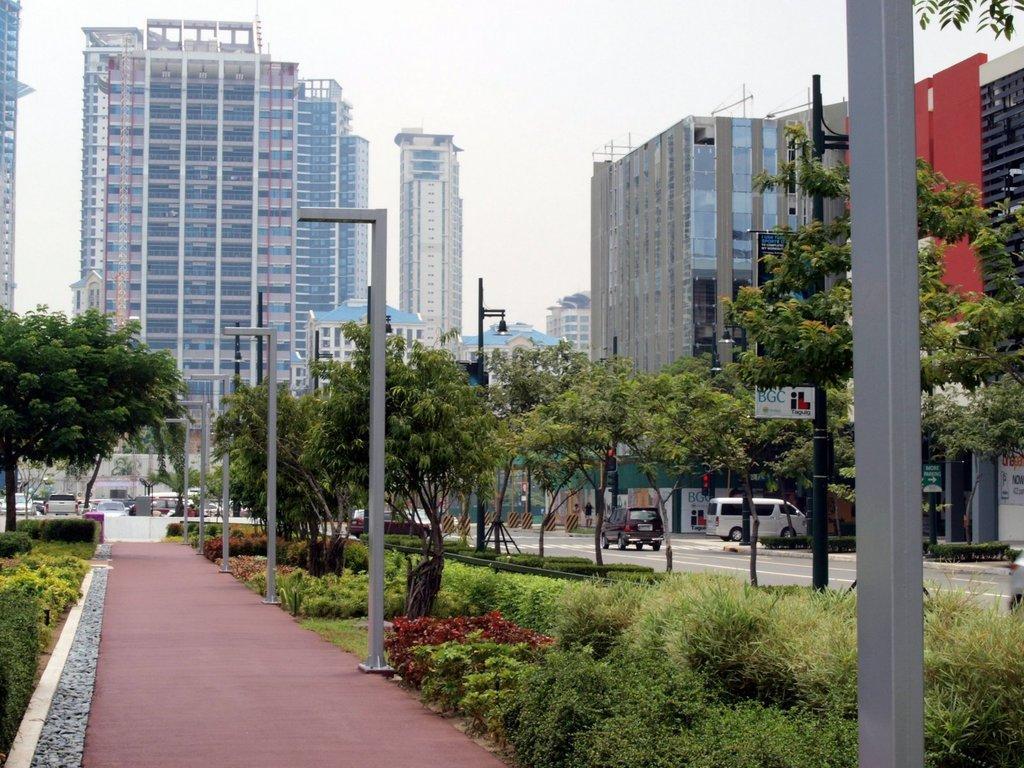Can you describe this image briefly? In the image there is a road and some vehicles are moving on the road, beside the road there is a garden with a lot of trees and plants, there are few plants in between those trees and in the background there are plenty of buildings and towers. 